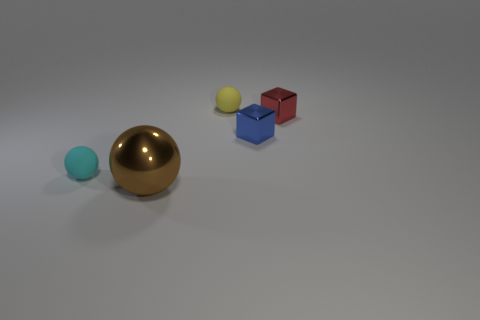Add 3 red objects. How many objects exist? 8 Subtract all balls. How many objects are left? 2 Subtract 0 blue spheres. How many objects are left? 5 Subtract all big brown shiny spheres. Subtract all cyan objects. How many objects are left? 3 Add 3 big brown metal balls. How many big brown metal balls are left? 4 Add 5 small green rubber cubes. How many small green rubber cubes exist? 5 